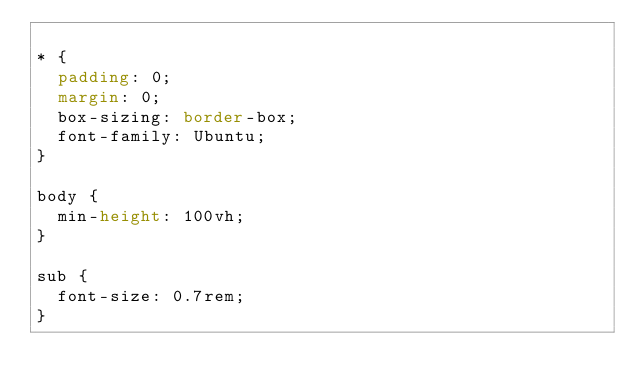Convert code to text. <code><loc_0><loc_0><loc_500><loc_500><_CSS_>
* {
  padding: 0;
  margin: 0;
  box-sizing: border-box;
  font-family: Ubuntu;
}

body {
  min-height: 100vh;
}

sub {
  font-size: 0.7rem;
}
</code> 